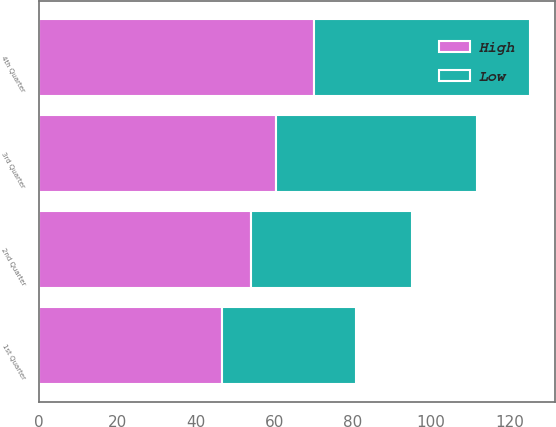Convert chart to OTSL. <chart><loc_0><loc_0><loc_500><loc_500><stacked_bar_chart><ecel><fcel>1st Quarter<fcel>2nd Quarter<fcel>3rd Quarter<fcel>4th Quarter<nl><fcel>High<fcel>46.6<fcel>54.15<fcel>60.32<fcel>70<nl><fcel>Low<fcel>34.17<fcel>40.89<fcel>51.5<fcel>55.34<nl></chart> 